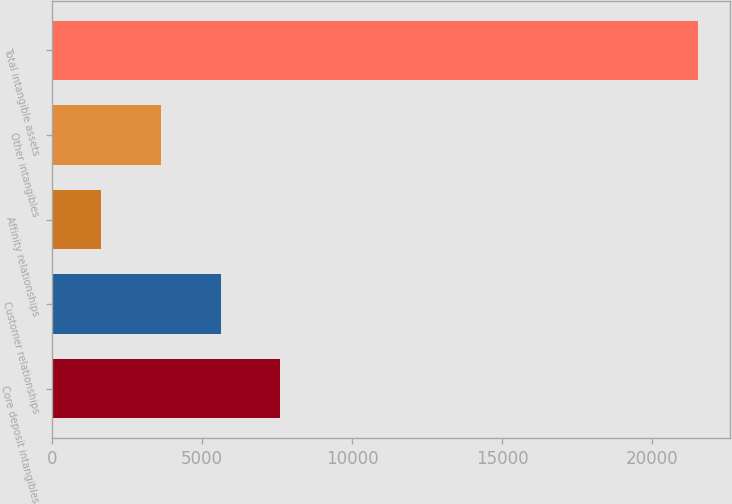Convert chart to OTSL. <chart><loc_0><loc_0><loc_500><loc_500><bar_chart><fcel>Core deposit intangibles<fcel>Customer relationships<fcel>Affinity relationships<fcel>Other intangibles<fcel>Total intangible assets<nl><fcel>7609.5<fcel>5622<fcel>1647<fcel>3634.5<fcel>21522<nl></chart> 